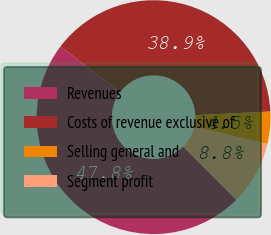Convert chart. <chart><loc_0><loc_0><loc_500><loc_500><pie_chart><fcel>Revenues<fcel>Costs of revenue exclusive of<fcel>Selling general and<fcel>Segment profit<nl><fcel>47.83%<fcel>38.91%<fcel>4.46%<fcel>8.8%<nl></chart> 